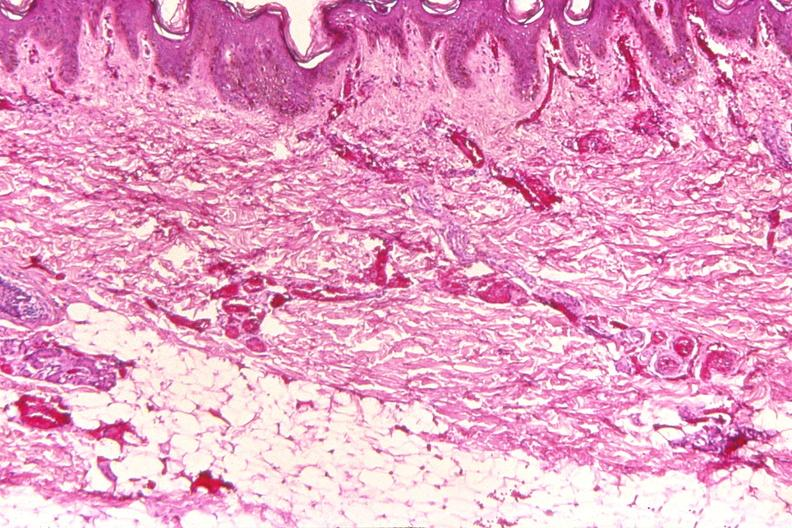does this image show skin, petechial hemorrhages from patient with meningococcemia?
Answer the question using a single word or phrase. Yes 